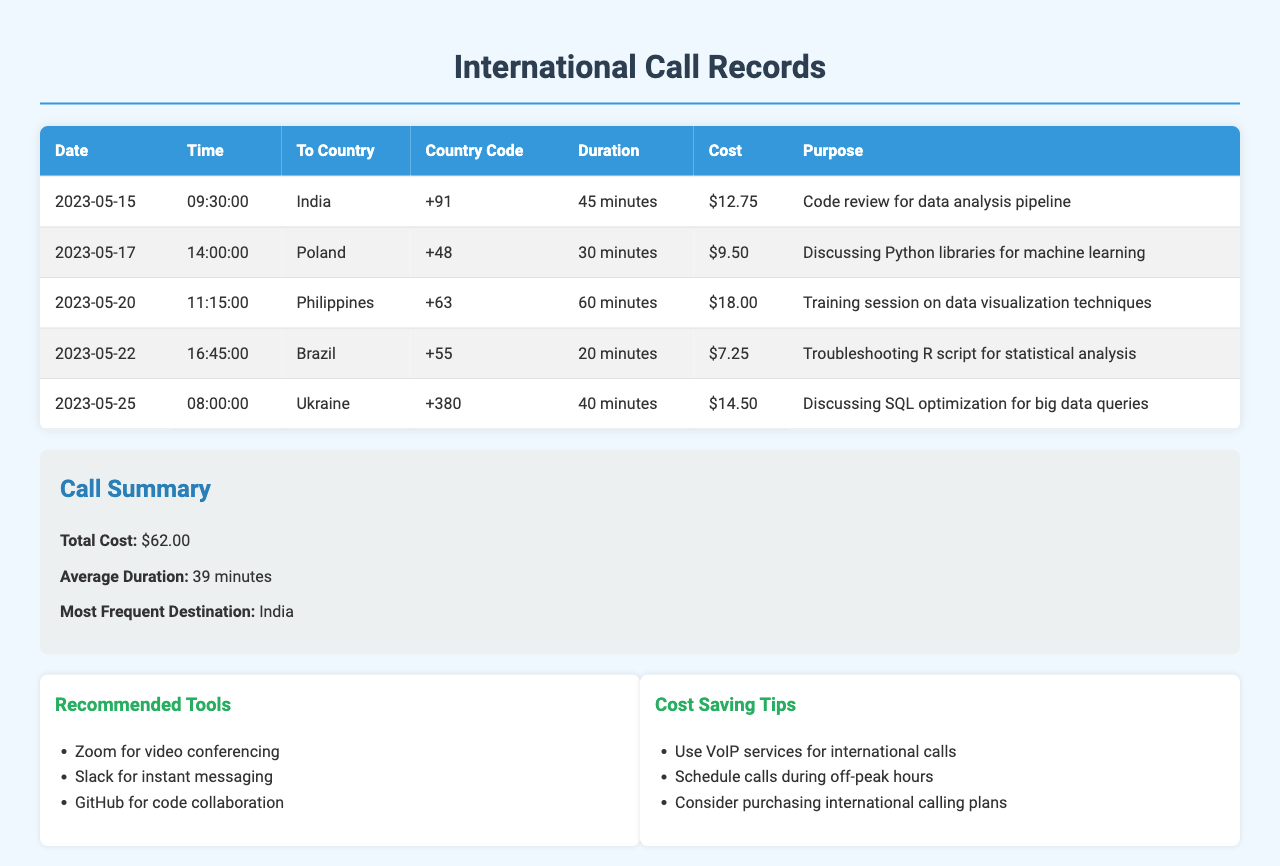What is the total cost of all calls? The total cost is provided in the summary section of the document, calculated from the individual call costs listed.
Answer: $62.00 Which country was called the most frequently? The summary section specifies the most frequent destination based on the call records provided.
Answer: India What is the duration of the call to the Philippines? The duration is listed in the table for the specific call to the Philippines.
Answer: 60 minutes What was the purpose of the call made to Ukraine? The purpose is detailed in the table under the corresponding row for Ukraine.
Answer: Discussing SQL optimization for big data queries What is the average duration of the calls? The average duration is provided in the summary section, derived from the total duration of all calls.
Answer: 39 minutes What is the cost of the call to Brazil? The cost is explicitly indicated in the table for the call made to Brazil.
Answer: $7.25 What was the date of the call to Poland? The date is specified in the table under the Poland row.
Answer: 2023-05-17 How long did the call to India last? The duration of the call to India is mentioned in the table.
Answer: 45 minutes How many minutes was the call made on May 22? The duration for the call on that date is provided in the respective row of the table.
Answer: 20 minutes 